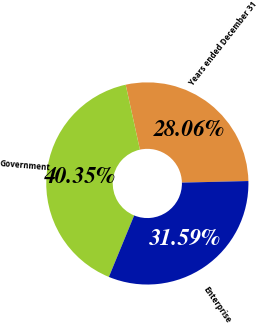<chart> <loc_0><loc_0><loc_500><loc_500><pie_chart><fcel>Years ended December 31<fcel>Government<fcel>Enterprise<nl><fcel>28.06%<fcel>40.35%<fcel>31.59%<nl></chart> 